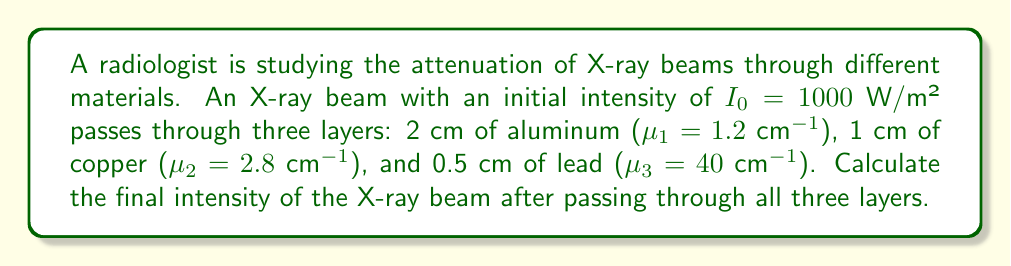Could you help me with this problem? To solve this problem, we'll use the Beer-Lambert law for X-ray attenuation through multiple layers:

$$I = I_0 \cdot e^{-(\mu_1x_1 + \mu_2x_2 + \mu_3x_3)}$$

Where:
$I_0$ is the initial intensity
$I$ is the final intensity
$\mu_i$ is the linear attenuation coefficient of material $i$
$x_i$ is the thickness of material $i$

Step 1: Substitute the given values into the equation:
$$I = 1000 \cdot e^{-(1.2 \cdot 2 + 2.8 \cdot 1 + 40 \cdot 0.5)}$$

Step 2: Simplify the exponent:
$$I = 1000 \cdot e^{-(2.4 + 2.8 + 20)}$$
$$I = 1000 \cdot e^{-25.2}$$

Step 3: Calculate the final intensity:
$$I = 1000 \cdot e^{-25.2} \approx 1.25 \times 10^{-9} \text{ W/m²}$$

The final intensity is approximately $1.25 \times 10^{-9}$ W/m².
Answer: $1.25 \times 10^{-9}$ W/m² 